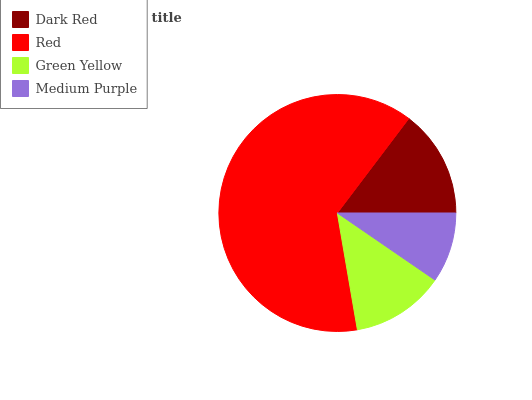Is Medium Purple the minimum?
Answer yes or no. Yes. Is Red the maximum?
Answer yes or no. Yes. Is Green Yellow the minimum?
Answer yes or no. No. Is Green Yellow the maximum?
Answer yes or no. No. Is Red greater than Green Yellow?
Answer yes or no. Yes. Is Green Yellow less than Red?
Answer yes or no. Yes. Is Green Yellow greater than Red?
Answer yes or no. No. Is Red less than Green Yellow?
Answer yes or no. No. Is Dark Red the high median?
Answer yes or no. Yes. Is Green Yellow the low median?
Answer yes or no. Yes. Is Green Yellow the high median?
Answer yes or no. No. Is Medium Purple the low median?
Answer yes or no. No. 